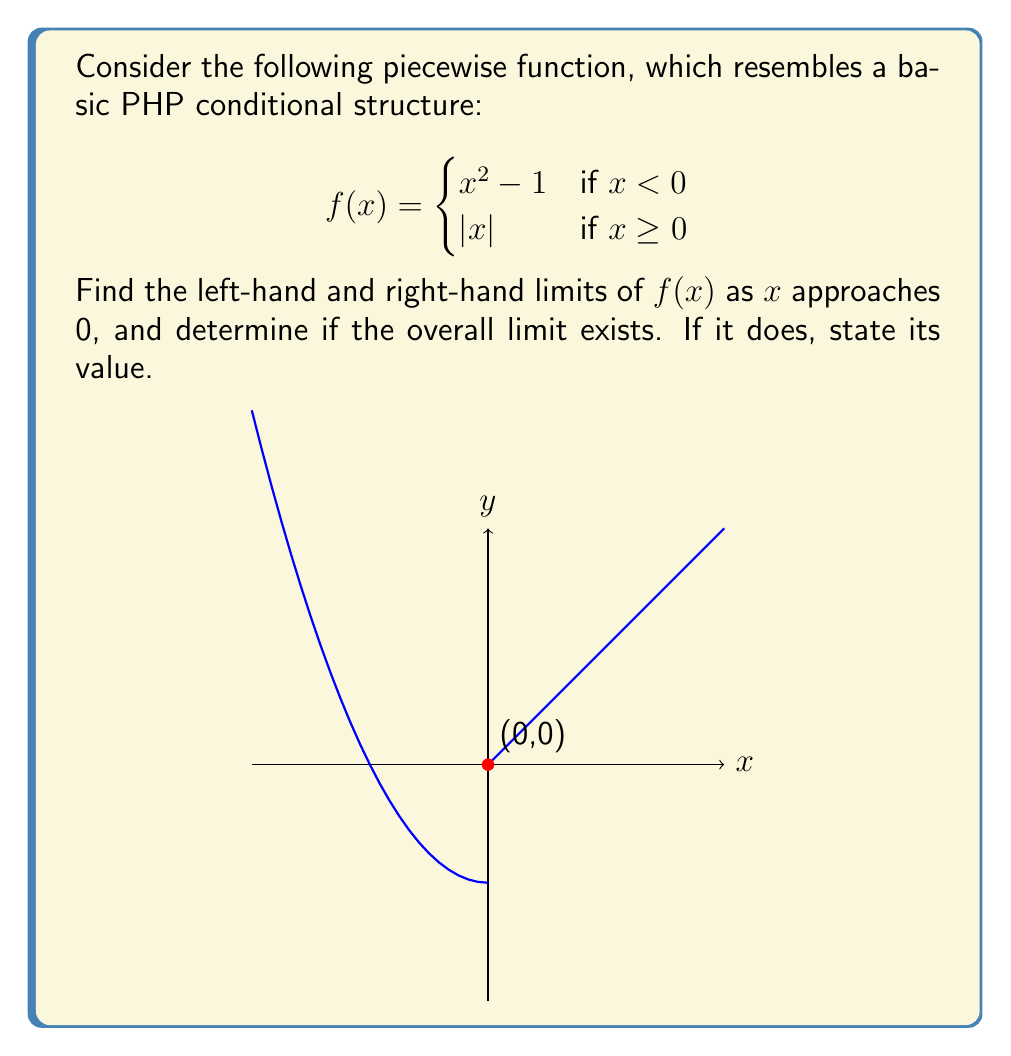Can you answer this question? Let's approach this problem step-by-step, similar to how we would structure a PHP function:

1) First, let's find the left-hand limit:
   As $x$ approaches 0 from the left, we use the first piece of the function: $x^2 - 1$
   
   $$\lim_{x \to 0^-} f(x) = \lim_{x \to 0^-} (x^2 - 1) = 0^2 - 1 = -1$$

2) Now, let's find the right-hand limit:
   As $x$ approaches 0 from the right, we use the second piece of the function: $|x|$
   
   $$\lim_{x \to 0^+} f(x) = \lim_{x \to 0^+} |x| = |0| = 0$$

3) For the overall limit to exist, both one-sided limits must exist and be equal.
   Here, we see that:
   
   $$\lim_{x \to 0^-} f(x) = -1 \neq 0 = \lim_{x \to 0^+} f(x)$$

4) Since the left-hand and right-hand limits are not equal, the overall limit does not exist.

This is analogous to an if-else structure in PHP where different code blocks are executed based on a condition, resulting in different outcomes.
Answer: The left-hand limit is -1, the right-hand limit is 0, and the overall limit does not exist. 